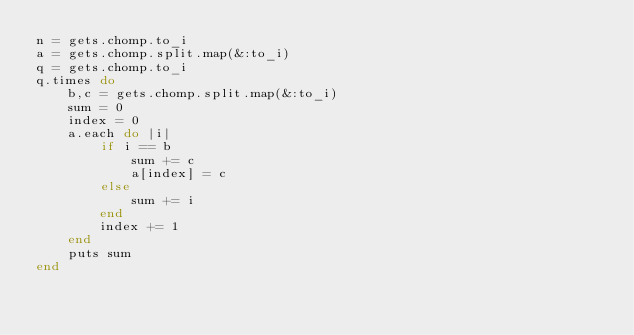<code> <loc_0><loc_0><loc_500><loc_500><_Ruby_>n = gets.chomp.to_i
a = gets.chomp.split.map(&:to_i)
q = gets.chomp.to_i
q.times do
    b,c = gets.chomp.split.map(&:to_i)
    sum = 0
    index = 0
    a.each do |i|
        if i == b
            sum += c
            a[index] = c
        else
            sum += i
        end
        index += 1
    end
    puts sum
end</code> 